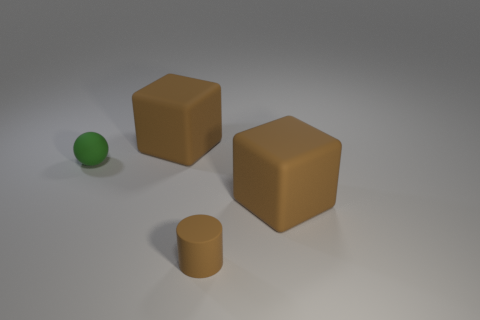If I wanted to recreate this scene at home, what objects would I need? To recreate this scene, you would need two identical cubes, one cylinder, and one small green sphere that has a shiny surface. The materials should ideally have a matte finish, except for the green ball, which should be rubbery and reflective. 